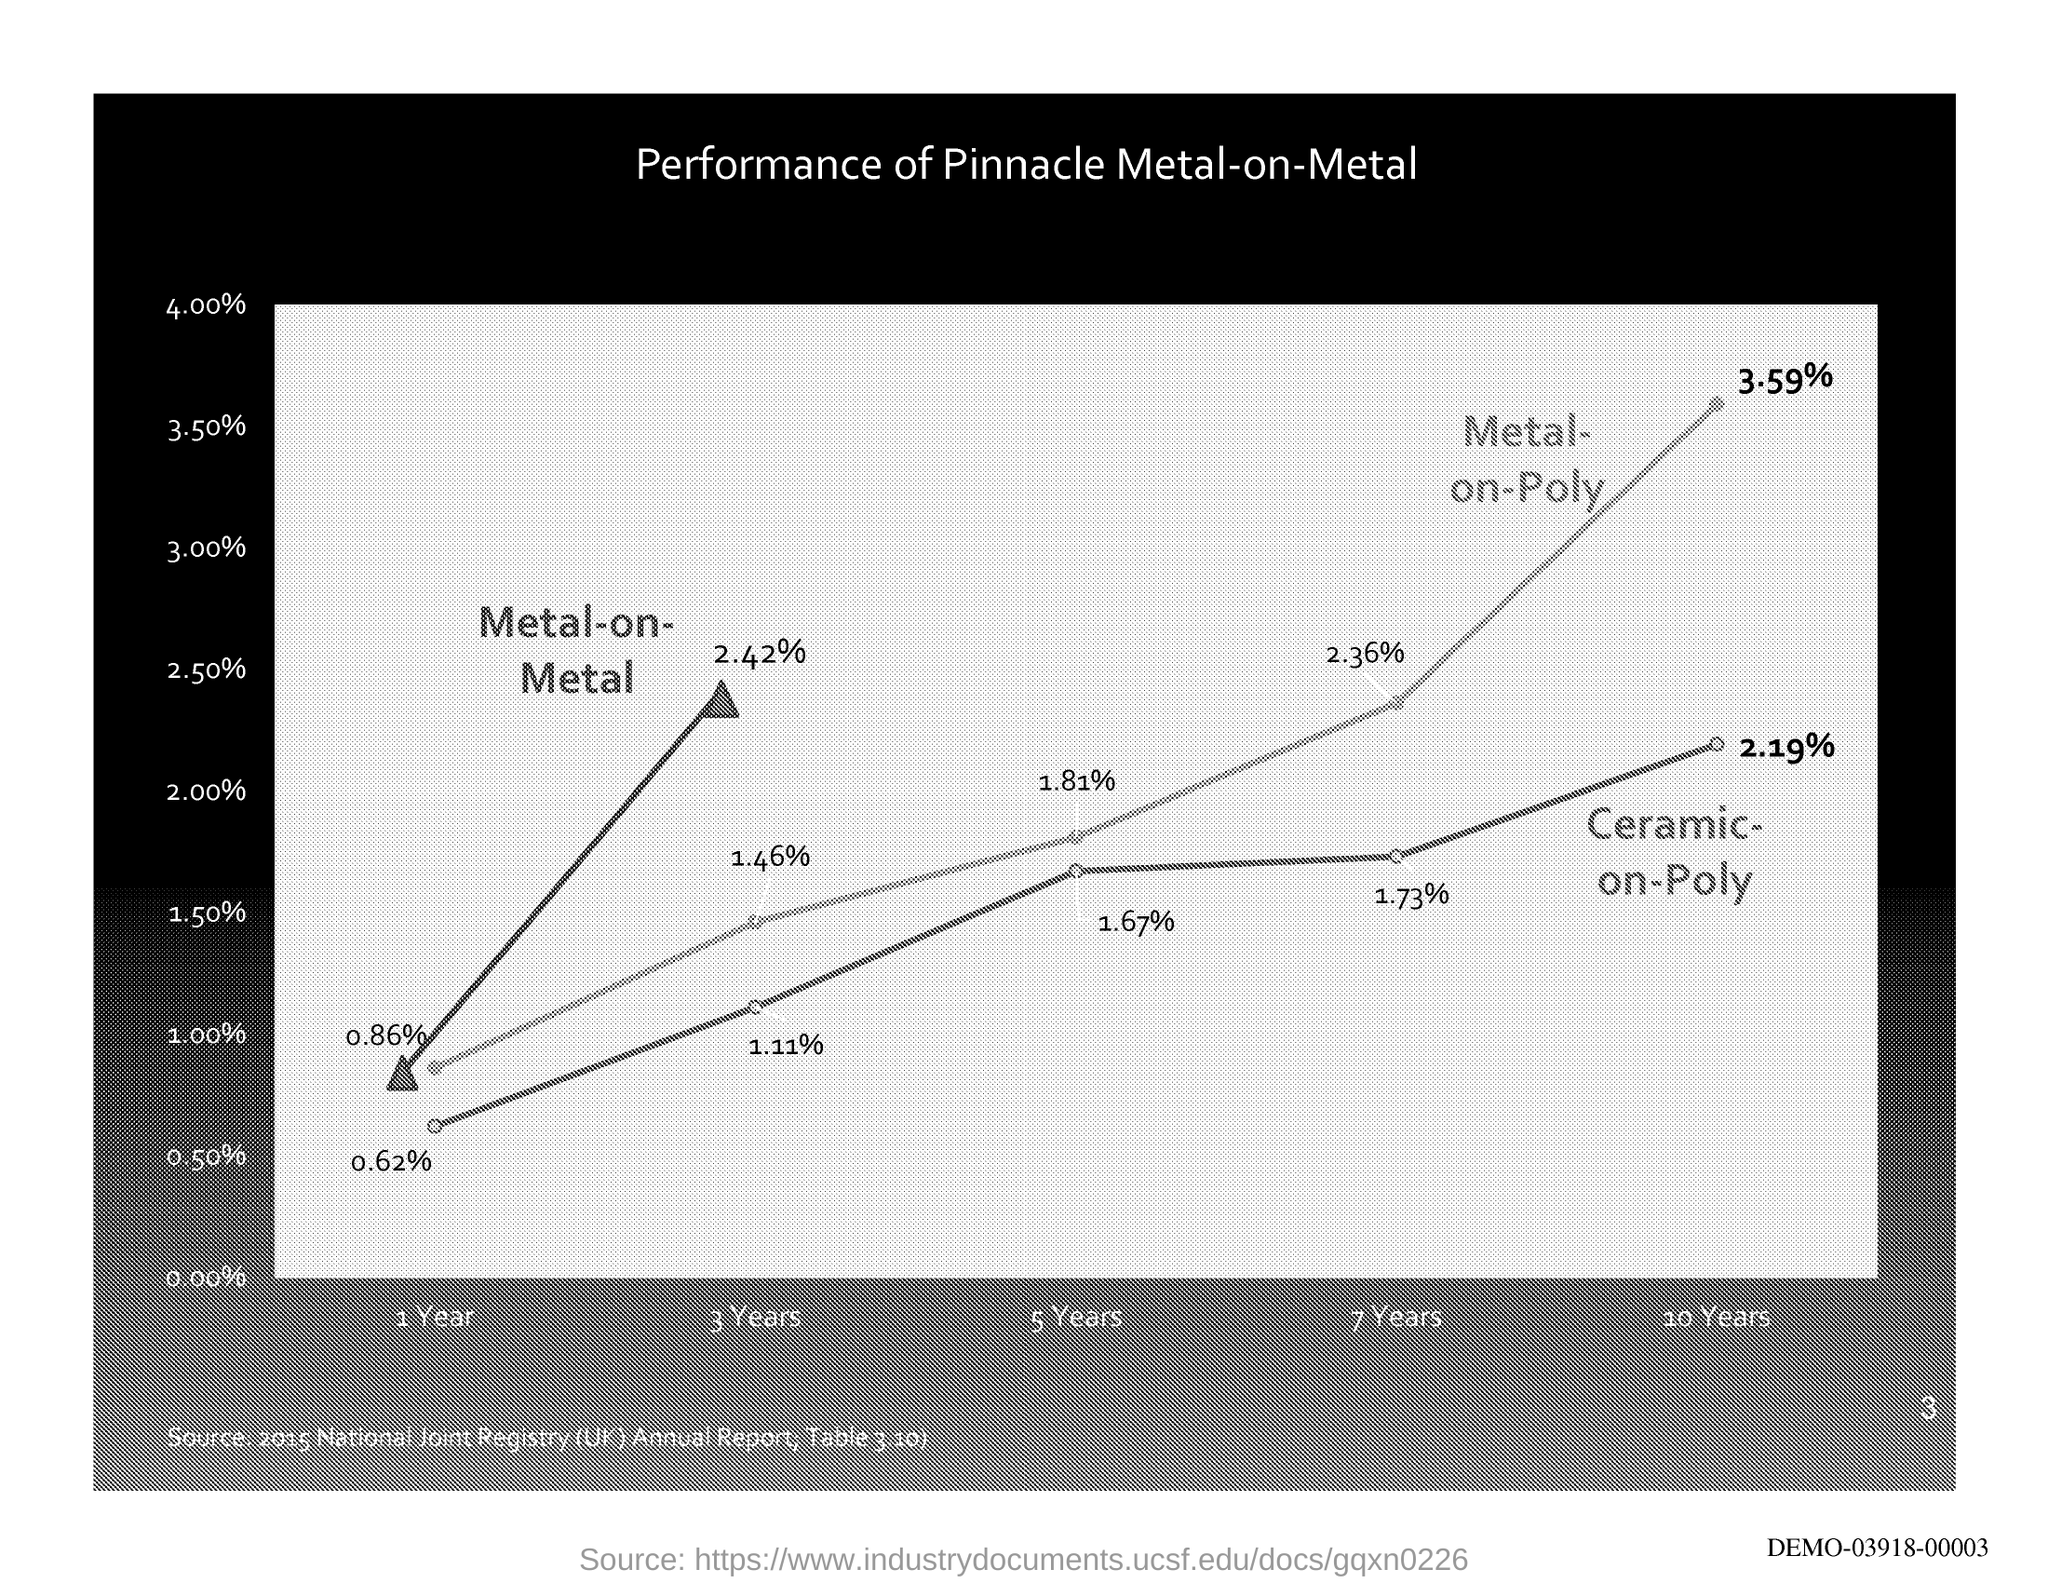Outline some significant characteristics in this image. There is a 0.86% chance of experiencing metal-on-metal hip implant failure within the first year of implantation. After 3 years, the percentage of metal-on-metal was found to be 2.42%. After three years, the percentage of metal on poly has been found to be 1.46%. According to the data, the metal-on-poly percentage for the fifth year is 1.81%. 